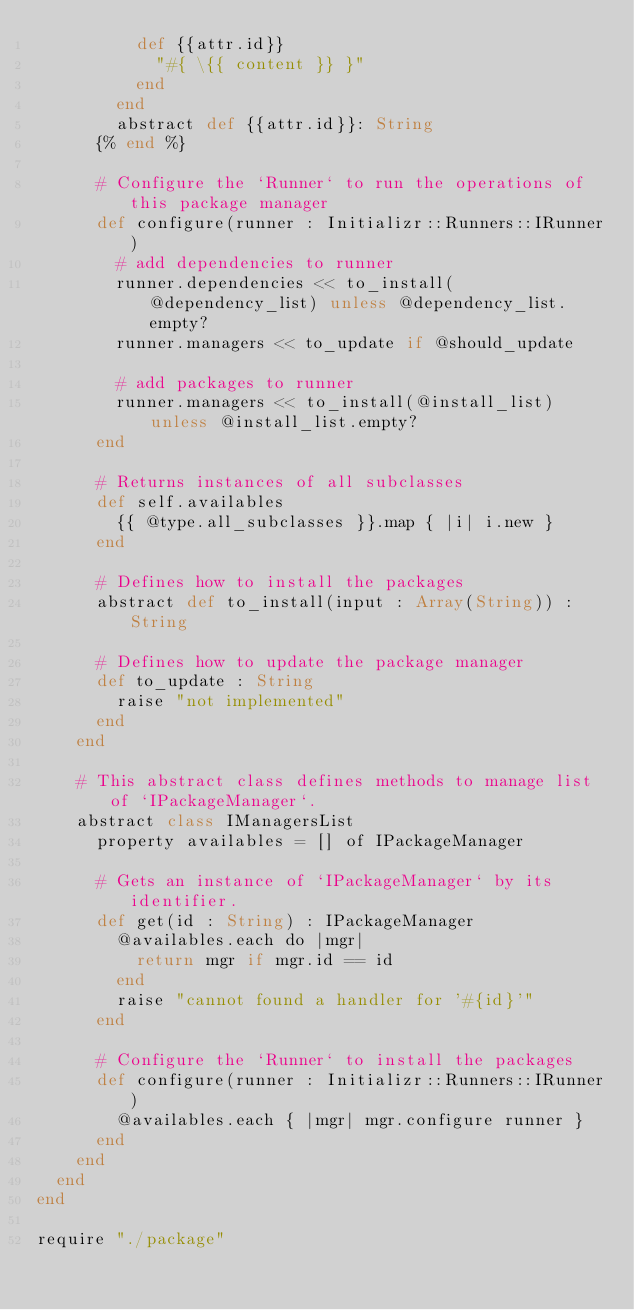<code> <loc_0><loc_0><loc_500><loc_500><_Crystal_>          def {{attr.id}}
            "#{ \{{ content }} }"
          end
        end
        abstract def {{attr.id}}: String
      {% end %}

      # Configure the `Runner` to run the operations of this package manager
      def configure(runner : Initializr::Runners::IRunner)
        # add dependencies to runner
        runner.dependencies << to_install(@dependency_list) unless @dependency_list.empty?
        runner.managers << to_update if @should_update

        # add packages to runner
        runner.managers << to_install(@install_list) unless @install_list.empty?
      end

      # Returns instances of all subclasses
      def self.availables
        {{ @type.all_subclasses }}.map { |i| i.new }
      end

      # Defines how to install the packages
      abstract def to_install(input : Array(String)) : String

      # Defines how to update the package manager
      def to_update : String
        raise "not implemented"
      end
    end

    # This abstract class defines methods to manage list of `IPackageManager`.
    abstract class IManagersList
      property availables = [] of IPackageManager

      # Gets an instance of `IPackageManager` by its identifier.
      def get(id : String) : IPackageManager
        @availables.each do |mgr|
          return mgr if mgr.id == id
        end
        raise "cannot found a handler for '#{id}'"
      end

      # Configure the `Runner` to install the packages
      def configure(runner : Initializr::Runners::IRunner)
        @availables.each { |mgr| mgr.configure runner }
      end
    end
  end
end

require "./package"
</code> 